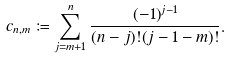<formula> <loc_0><loc_0><loc_500><loc_500>c _ { n , m } \coloneqq \sum _ { j = m + 1 } ^ { n } \frac { ( - 1 ) ^ { j - 1 } } { ( n - j ) ! ( j - 1 - m ) ! } .</formula> 